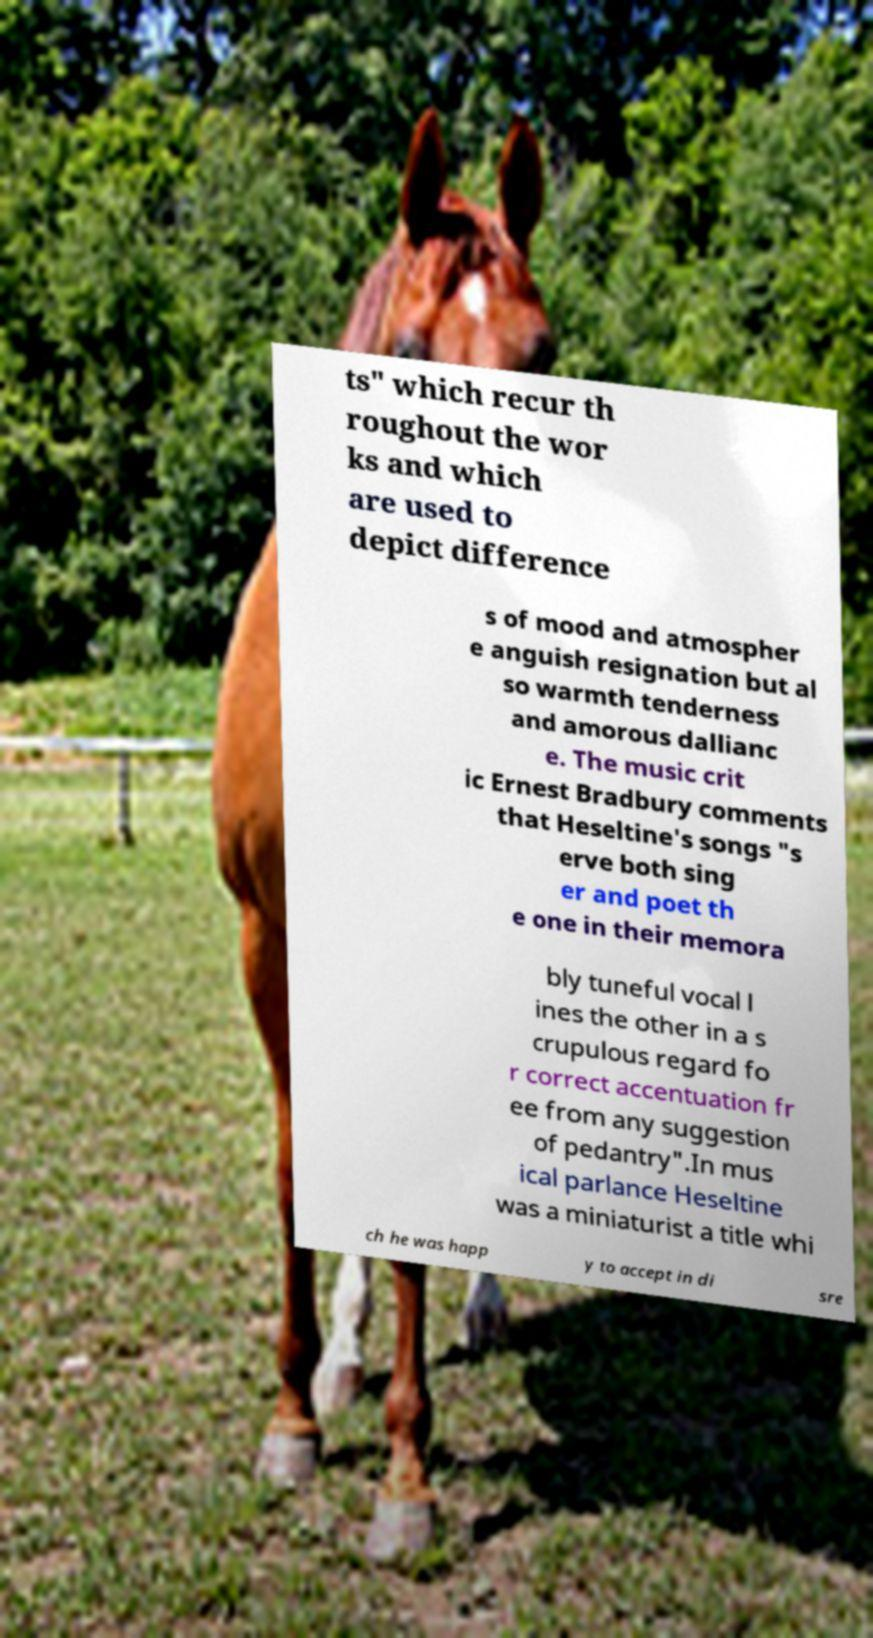Please identify and transcribe the text found in this image. ts" which recur th roughout the wor ks and which are used to depict difference s of mood and atmospher e anguish resignation but al so warmth tenderness and amorous dallianc e. The music crit ic Ernest Bradbury comments that Heseltine's songs "s erve both sing er and poet th e one in their memora bly tuneful vocal l ines the other in a s crupulous regard fo r correct accentuation fr ee from any suggestion of pedantry".In mus ical parlance Heseltine was a miniaturist a title whi ch he was happ y to accept in di sre 